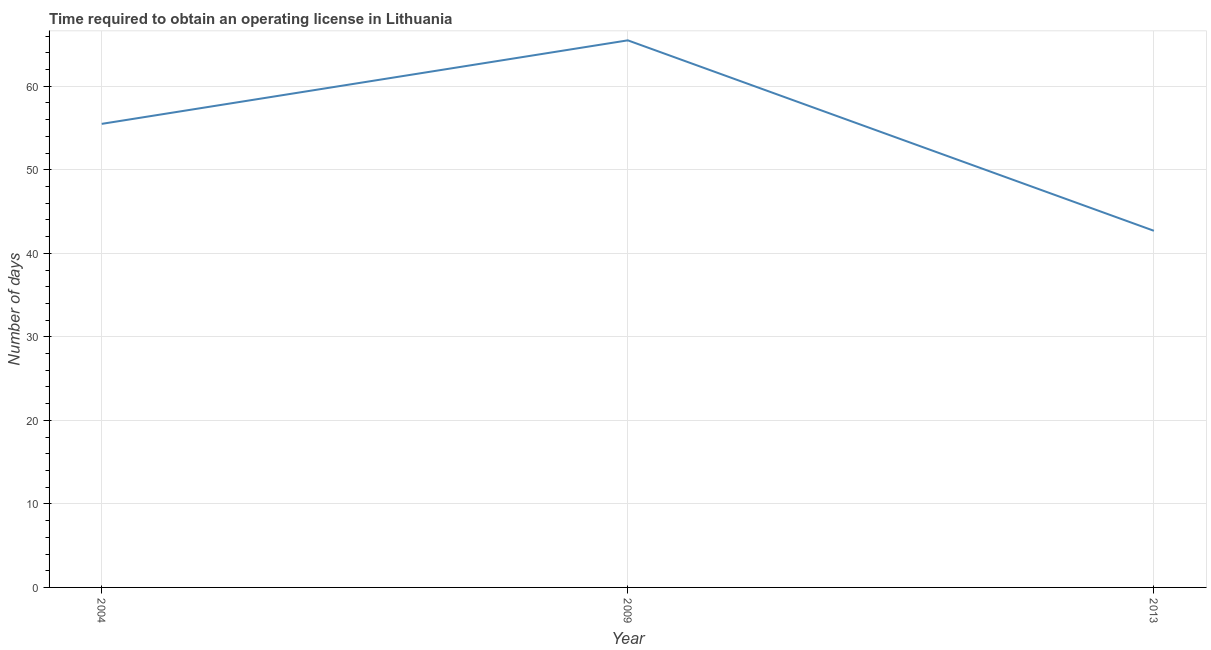What is the number of days to obtain operating license in 2004?
Your answer should be very brief. 55.5. Across all years, what is the maximum number of days to obtain operating license?
Make the answer very short. 65.5. Across all years, what is the minimum number of days to obtain operating license?
Give a very brief answer. 42.7. In which year was the number of days to obtain operating license minimum?
Ensure brevity in your answer.  2013. What is the sum of the number of days to obtain operating license?
Provide a short and direct response. 163.7. What is the difference between the number of days to obtain operating license in 2009 and 2013?
Your answer should be very brief. 22.8. What is the average number of days to obtain operating license per year?
Your response must be concise. 54.57. What is the median number of days to obtain operating license?
Provide a short and direct response. 55.5. Do a majority of the years between 2013 and 2004 (inclusive) have number of days to obtain operating license greater than 26 days?
Your response must be concise. No. What is the ratio of the number of days to obtain operating license in 2004 to that in 2009?
Your answer should be compact. 0.85. Is the number of days to obtain operating license in 2004 less than that in 2013?
Keep it short and to the point. No. Is the sum of the number of days to obtain operating license in 2004 and 2013 greater than the maximum number of days to obtain operating license across all years?
Keep it short and to the point. Yes. What is the difference between the highest and the lowest number of days to obtain operating license?
Make the answer very short. 22.8. In how many years, is the number of days to obtain operating license greater than the average number of days to obtain operating license taken over all years?
Offer a terse response. 2. How many years are there in the graph?
Your response must be concise. 3. What is the difference between two consecutive major ticks on the Y-axis?
Give a very brief answer. 10. What is the title of the graph?
Your response must be concise. Time required to obtain an operating license in Lithuania. What is the label or title of the Y-axis?
Keep it short and to the point. Number of days. What is the Number of days of 2004?
Provide a succinct answer. 55.5. What is the Number of days of 2009?
Keep it short and to the point. 65.5. What is the Number of days in 2013?
Your answer should be very brief. 42.7. What is the difference between the Number of days in 2004 and 2009?
Provide a succinct answer. -10. What is the difference between the Number of days in 2004 and 2013?
Provide a short and direct response. 12.8. What is the difference between the Number of days in 2009 and 2013?
Keep it short and to the point. 22.8. What is the ratio of the Number of days in 2004 to that in 2009?
Offer a very short reply. 0.85. What is the ratio of the Number of days in 2009 to that in 2013?
Keep it short and to the point. 1.53. 